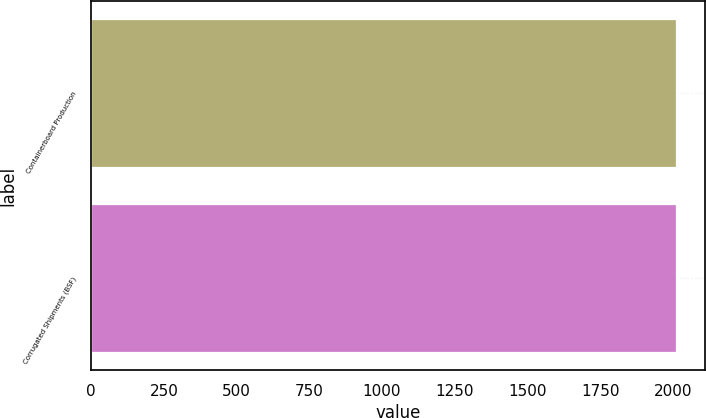Convert chart to OTSL. <chart><loc_0><loc_0><loc_500><loc_500><bar_chart><fcel>Containerboard Production<fcel>Corrugated Shipments (BSF)<nl><fcel>2010<fcel>2010.1<nl></chart> 